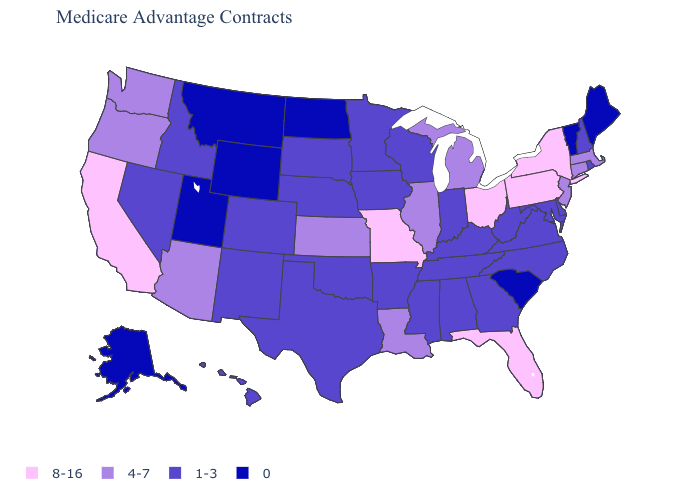What is the value of Louisiana?
Write a very short answer. 4-7. Name the states that have a value in the range 0?
Quick response, please. Alaska, Maine, Montana, North Dakota, South Carolina, Utah, Vermont, Wyoming. What is the value of Pennsylvania?
Answer briefly. 8-16. Among the states that border Idaho , which have the highest value?
Concise answer only. Oregon, Washington. Does New Jersey have the lowest value in the USA?
Concise answer only. No. What is the lowest value in states that border Washington?
Short answer required. 1-3. Does Montana have the lowest value in the USA?
Short answer required. Yes. What is the value of Ohio?
Give a very brief answer. 8-16. Is the legend a continuous bar?
Quick response, please. No. What is the highest value in states that border Utah?
Keep it brief. 4-7. What is the highest value in the USA?
Be succinct. 8-16. What is the highest value in states that border South Dakota?
Quick response, please. 1-3. Does Ohio have the highest value in the MidWest?
Write a very short answer. Yes. What is the lowest value in the USA?
Write a very short answer. 0. 